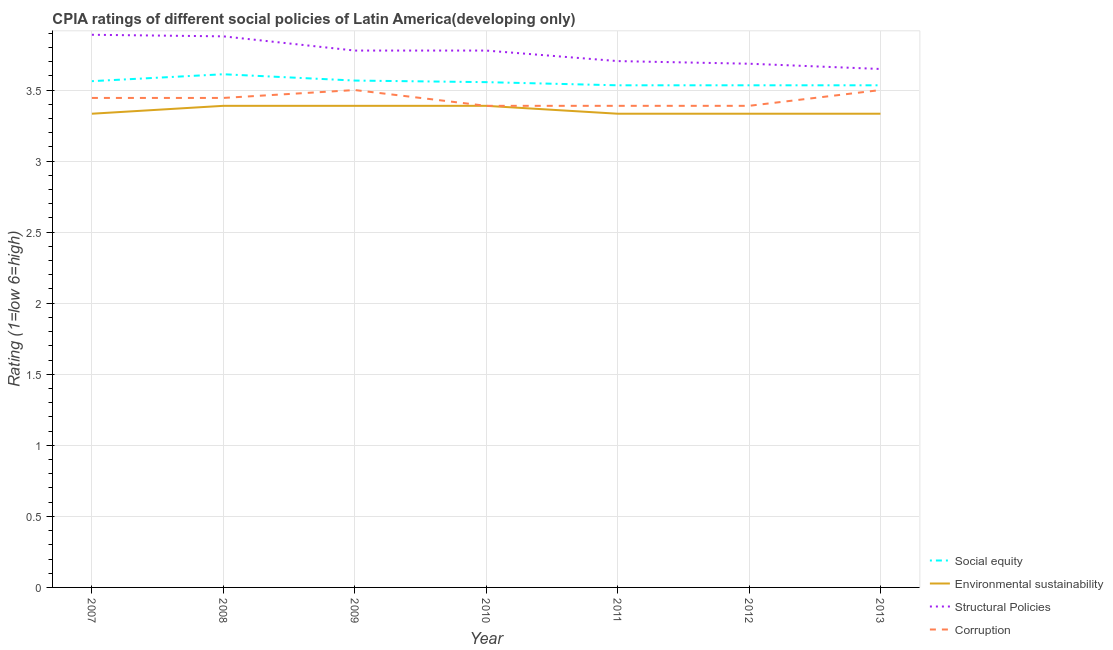Is the number of lines equal to the number of legend labels?
Give a very brief answer. Yes. What is the cpia rating of environmental sustainability in 2012?
Your response must be concise. 3.33. Across all years, what is the minimum cpia rating of corruption?
Make the answer very short. 3.39. What is the total cpia rating of corruption in the graph?
Your response must be concise. 24.06. What is the difference between the cpia rating of social equity in 2009 and the cpia rating of environmental sustainability in 2008?
Ensure brevity in your answer.  0.18. What is the average cpia rating of environmental sustainability per year?
Your answer should be very brief. 3.36. In the year 2011, what is the difference between the cpia rating of environmental sustainability and cpia rating of corruption?
Your answer should be compact. -0.06. In how many years, is the cpia rating of environmental sustainability greater than 2.7?
Give a very brief answer. 7. What is the ratio of the cpia rating of environmental sustainability in 2007 to that in 2012?
Provide a short and direct response. 1. Is the cpia rating of environmental sustainability in 2007 less than that in 2012?
Provide a succinct answer. No. What is the difference between the highest and the second highest cpia rating of social equity?
Make the answer very short. 0.04. What is the difference between the highest and the lowest cpia rating of environmental sustainability?
Offer a very short reply. 0.06. In how many years, is the cpia rating of corruption greater than the average cpia rating of corruption taken over all years?
Make the answer very short. 4. Is the sum of the cpia rating of structural policies in 2007 and 2010 greater than the maximum cpia rating of social equity across all years?
Ensure brevity in your answer.  Yes. Is it the case that in every year, the sum of the cpia rating of corruption and cpia rating of social equity is greater than the sum of cpia rating of environmental sustainability and cpia rating of structural policies?
Ensure brevity in your answer.  No. Is it the case that in every year, the sum of the cpia rating of social equity and cpia rating of environmental sustainability is greater than the cpia rating of structural policies?
Your response must be concise. Yes. Is the cpia rating of corruption strictly greater than the cpia rating of environmental sustainability over the years?
Provide a succinct answer. No. Is the cpia rating of corruption strictly less than the cpia rating of environmental sustainability over the years?
Your answer should be compact. No. How many lines are there?
Offer a terse response. 4. How many years are there in the graph?
Your answer should be compact. 7. Are the values on the major ticks of Y-axis written in scientific E-notation?
Make the answer very short. No. Does the graph contain any zero values?
Your answer should be compact. No. Where does the legend appear in the graph?
Provide a short and direct response. Bottom right. What is the title of the graph?
Your answer should be very brief. CPIA ratings of different social policies of Latin America(developing only). What is the Rating (1=low 6=high) of Social equity in 2007?
Your response must be concise. 3.56. What is the Rating (1=low 6=high) in Environmental sustainability in 2007?
Offer a terse response. 3.33. What is the Rating (1=low 6=high) of Structural Policies in 2007?
Offer a very short reply. 3.89. What is the Rating (1=low 6=high) in Corruption in 2007?
Provide a succinct answer. 3.44. What is the Rating (1=low 6=high) of Social equity in 2008?
Your answer should be compact. 3.61. What is the Rating (1=low 6=high) of Environmental sustainability in 2008?
Your response must be concise. 3.39. What is the Rating (1=low 6=high) of Structural Policies in 2008?
Make the answer very short. 3.88. What is the Rating (1=low 6=high) in Corruption in 2008?
Give a very brief answer. 3.44. What is the Rating (1=low 6=high) in Social equity in 2009?
Your answer should be very brief. 3.57. What is the Rating (1=low 6=high) of Environmental sustainability in 2009?
Provide a short and direct response. 3.39. What is the Rating (1=low 6=high) of Structural Policies in 2009?
Ensure brevity in your answer.  3.78. What is the Rating (1=low 6=high) of Corruption in 2009?
Make the answer very short. 3.5. What is the Rating (1=low 6=high) in Social equity in 2010?
Give a very brief answer. 3.56. What is the Rating (1=low 6=high) in Environmental sustainability in 2010?
Offer a very short reply. 3.39. What is the Rating (1=low 6=high) of Structural Policies in 2010?
Offer a terse response. 3.78. What is the Rating (1=low 6=high) in Corruption in 2010?
Provide a succinct answer. 3.39. What is the Rating (1=low 6=high) of Social equity in 2011?
Provide a succinct answer. 3.53. What is the Rating (1=low 6=high) in Environmental sustainability in 2011?
Give a very brief answer. 3.33. What is the Rating (1=low 6=high) in Structural Policies in 2011?
Offer a terse response. 3.7. What is the Rating (1=low 6=high) in Corruption in 2011?
Keep it short and to the point. 3.39. What is the Rating (1=low 6=high) in Social equity in 2012?
Provide a succinct answer. 3.53. What is the Rating (1=low 6=high) of Environmental sustainability in 2012?
Your response must be concise. 3.33. What is the Rating (1=low 6=high) of Structural Policies in 2012?
Keep it short and to the point. 3.69. What is the Rating (1=low 6=high) in Corruption in 2012?
Give a very brief answer. 3.39. What is the Rating (1=low 6=high) of Social equity in 2013?
Offer a very short reply. 3.53. What is the Rating (1=low 6=high) in Environmental sustainability in 2013?
Offer a very short reply. 3.33. What is the Rating (1=low 6=high) of Structural Policies in 2013?
Your response must be concise. 3.65. Across all years, what is the maximum Rating (1=low 6=high) of Social equity?
Ensure brevity in your answer.  3.61. Across all years, what is the maximum Rating (1=low 6=high) in Environmental sustainability?
Offer a terse response. 3.39. Across all years, what is the maximum Rating (1=low 6=high) in Structural Policies?
Your response must be concise. 3.89. Across all years, what is the minimum Rating (1=low 6=high) of Social equity?
Your answer should be compact. 3.53. Across all years, what is the minimum Rating (1=low 6=high) of Environmental sustainability?
Keep it short and to the point. 3.33. Across all years, what is the minimum Rating (1=low 6=high) in Structural Policies?
Offer a very short reply. 3.65. Across all years, what is the minimum Rating (1=low 6=high) in Corruption?
Provide a succinct answer. 3.39. What is the total Rating (1=low 6=high) of Social equity in the graph?
Offer a very short reply. 24.9. What is the total Rating (1=low 6=high) in Environmental sustainability in the graph?
Provide a short and direct response. 23.5. What is the total Rating (1=low 6=high) in Structural Policies in the graph?
Give a very brief answer. 26.36. What is the total Rating (1=low 6=high) of Corruption in the graph?
Give a very brief answer. 24.06. What is the difference between the Rating (1=low 6=high) in Social equity in 2007 and that in 2008?
Provide a short and direct response. -0.05. What is the difference between the Rating (1=low 6=high) in Environmental sustainability in 2007 and that in 2008?
Make the answer very short. -0.06. What is the difference between the Rating (1=low 6=high) of Structural Policies in 2007 and that in 2008?
Your answer should be very brief. 0.01. What is the difference between the Rating (1=low 6=high) of Social equity in 2007 and that in 2009?
Give a very brief answer. -0. What is the difference between the Rating (1=low 6=high) of Environmental sustainability in 2007 and that in 2009?
Offer a very short reply. -0.06. What is the difference between the Rating (1=low 6=high) in Structural Policies in 2007 and that in 2009?
Provide a succinct answer. 0.11. What is the difference between the Rating (1=low 6=high) of Corruption in 2007 and that in 2009?
Your response must be concise. -0.06. What is the difference between the Rating (1=low 6=high) in Social equity in 2007 and that in 2010?
Keep it short and to the point. 0.01. What is the difference between the Rating (1=low 6=high) of Environmental sustainability in 2007 and that in 2010?
Your response must be concise. -0.06. What is the difference between the Rating (1=low 6=high) in Structural Policies in 2007 and that in 2010?
Your answer should be very brief. 0.11. What is the difference between the Rating (1=low 6=high) in Corruption in 2007 and that in 2010?
Offer a very short reply. 0.06. What is the difference between the Rating (1=low 6=high) in Social equity in 2007 and that in 2011?
Offer a very short reply. 0.03. What is the difference between the Rating (1=low 6=high) in Environmental sustainability in 2007 and that in 2011?
Keep it short and to the point. 0. What is the difference between the Rating (1=low 6=high) in Structural Policies in 2007 and that in 2011?
Provide a short and direct response. 0.19. What is the difference between the Rating (1=low 6=high) of Corruption in 2007 and that in 2011?
Your response must be concise. 0.06. What is the difference between the Rating (1=low 6=high) of Social equity in 2007 and that in 2012?
Make the answer very short. 0.03. What is the difference between the Rating (1=low 6=high) of Structural Policies in 2007 and that in 2012?
Offer a very short reply. 0.2. What is the difference between the Rating (1=low 6=high) of Corruption in 2007 and that in 2012?
Offer a terse response. 0.06. What is the difference between the Rating (1=low 6=high) in Social equity in 2007 and that in 2013?
Make the answer very short. 0.03. What is the difference between the Rating (1=low 6=high) in Structural Policies in 2007 and that in 2013?
Provide a short and direct response. 0.24. What is the difference between the Rating (1=low 6=high) of Corruption in 2007 and that in 2013?
Make the answer very short. -0.06. What is the difference between the Rating (1=low 6=high) in Social equity in 2008 and that in 2009?
Provide a succinct answer. 0.04. What is the difference between the Rating (1=low 6=high) in Environmental sustainability in 2008 and that in 2009?
Ensure brevity in your answer.  0. What is the difference between the Rating (1=low 6=high) of Corruption in 2008 and that in 2009?
Make the answer very short. -0.06. What is the difference between the Rating (1=low 6=high) in Social equity in 2008 and that in 2010?
Provide a succinct answer. 0.06. What is the difference between the Rating (1=low 6=high) of Environmental sustainability in 2008 and that in 2010?
Ensure brevity in your answer.  0. What is the difference between the Rating (1=low 6=high) of Structural Policies in 2008 and that in 2010?
Your answer should be very brief. 0.1. What is the difference between the Rating (1=low 6=high) of Corruption in 2008 and that in 2010?
Give a very brief answer. 0.06. What is the difference between the Rating (1=low 6=high) of Social equity in 2008 and that in 2011?
Give a very brief answer. 0.08. What is the difference between the Rating (1=low 6=high) of Environmental sustainability in 2008 and that in 2011?
Offer a very short reply. 0.06. What is the difference between the Rating (1=low 6=high) in Structural Policies in 2008 and that in 2011?
Ensure brevity in your answer.  0.17. What is the difference between the Rating (1=low 6=high) in Corruption in 2008 and that in 2011?
Provide a succinct answer. 0.06. What is the difference between the Rating (1=low 6=high) in Social equity in 2008 and that in 2012?
Your response must be concise. 0.08. What is the difference between the Rating (1=low 6=high) of Environmental sustainability in 2008 and that in 2012?
Make the answer very short. 0.06. What is the difference between the Rating (1=low 6=high) in Structural Policies in 2008 and that in 2012?
Keep it short and to the point. 0.19. What is the difference between the Rating (1=low 6=high) of Corruption in 2008 and that in 2012?
Make the answer very short. 0.06. What is the difference between the Rating (1=low 6=high) in Social equity in 2008 and that in 2013?
Provide a succinct answer. 0.08. What is the difference between the Rating (1=low 6=high) of Environmental sustainability in 2008 and that in 2013?
Ensure brevity in your answer.  0.06. What is the difference between the Rating (1=low 6=high) of Structural Policies in 2008 and that in 2013?
Provide a succinct answer. 0.23. What is the difference between the Rating (1=low 6=high) of Corruption in 2008 and that in 2013?
Offer a terse response. -0.06. What is the difference between the Rating (1=low 6=high) in Social equity in 2009 and that in 2010?
Your response must be concise. 0.01. What is the difference between the Rating (1=low 6=high) of Environmental sustainability in 2009 and that in 2010?
Your answer should be very brief. 0. What is the difference between the Rating (1=low 6=high) of Environmental sustainability in 2009 and that in 2011?
Provide a short and direct response. 0.06. What is the difference between the Rating (1=low 6=high) in Structural Policies in 2009 and that in 2011?
Provide a succinct answer. 0.07. What is the difference between the Rating (1=low 6=high) in Corruption in 2009 and that in 2011?
Your response must be concise. 0.11. What is the difference between the Rating (1=low 6=high) in Social equity in 2009 and that in 2012?
Your answer should be very brief. 0.03. What is the difference between the Rating (1=low 6=high) in Environmental sustainability in 2009 and that in 2012?
Your response must be concise. 0.06. What is the difference between the Rating (1=low 6=high) of Structural Policies in 2009 and that in 2012?
Keep it short and to the point. 0.09. What is the difference between the Rating (1=low 6=high) in Corruption in 2009 and that in 2012?
Provide a short and direct response. 0.11. What is the difference between the Rating (1=low 6=high) in Social equity in 2009 and that in 2013?
Give a very brief answer. 0.03. What is the difference between the Rating (1=low 6=high) in Environmental sustainability in 2009 and that in 2013?
Keep it short and to the point. 0.06. What is the difference between the Rating (1=low 6=high) of Structural Policies in 2009 and that in 2013?
Make the answer very short. 0.13. What is the difference between the Rating (1=low 6=high) in Social equity in 2010 and that in 2011?
Provide a short and direct response. 0.02. What is the difference between the Rating (1=low 6=high) of Environmental sustainability in 2010 and that in 2011?
Your answer should be very brief. 0.06. What is the difference between the Rating (1=low 6=high) in Structural Policies in 2010 and that in 2011?
Your response must be concise. 0.07. What is the difference between the Rating (1=low 6=high) of Social equity in 2010 and that in 2012?
Your response must be concise. 0.02. What is the difference between the Rating (1=low 6=high) in Environmental sustainability in 2010 and that in 2012?
Make the answer very short. 0.06. What is the difference between the Rating (1=low 6=high) of Structural Policies in 2010 and that in 2012?
Your answer should be very brief. 0.09. What is the difference between the Rating (1=low 6=high) of Social equity in 2010 and that in 2013?
Provide a succinct answer. 0.02. What is the difference between the Rating (1=low 6=high) in Environmental sustainability in 2010 and that in 2013?
Your answer should be compact. 0.06. What is the difference between the Rating (1=low 6=high) of Structural Policies in 2010 and that in 2013?
Provide a succinct answer. 0.13. What is the difference between the Rating (1=low 6=high) in Corruption in 2010 and that in 2013?
Offer a very short reply. -0.11. What is the difference between the Rating (1=low 6=high) in Social equity in 2011 and that in 2012?
Offer a terse response. 0. What is the difference between the Rating (1=low 6=high) of Structural Policies in 2011 and that in 2012?
Your answer should be compact. 0.02. What is the difference between the Rating (1=low 6=high) of Corruption in 2011 and that in 2012?
Make the answer very short. 0. What is the difference between the Rating (1=low 6=high) in Environmental sustainability in 2011 and that in 2013?
Provide a short and direct response. 0. What is the difference between the Rating (1=low 6=high) in Structural Policies in 2011 and that in 2013?
Your answer should be very brief. 0.06. What is the difference between the Rating (1=low 6=high) in Corruption in 2011 and that in 2013?
Offer a very short reply. -0.11. What is the difference between the Rating (1=low 6=high) in Structural Policies in 2012 and that in 2013?
Provide a short and direct response. 0.04. What is the difference between the Rating (1=low 6=high) in Corruption in 2012 and that in 2013?
Offer a terse response. -0.11. What is the difference between the Rating (1=low 6=high) in Social equity in 2007 and the Rating (1=low 6=high) in Environmental sustainability in 2008?
Provide a short and direct response. 0.17. What is the difference between the Rating (1=low 6=high) in Social equity in 2007 and the Rating (1=low 6=high) in Structural Policies in 2008?
Your answer should be compact. -0.32. What is the difference between the Rating (1=low 6=high) in Social equity in 2007 and the Rating (1=low 6=high) in Corruption in 2008?
Make the answer very short. 0.12. What is the difference between the Rating (1=low 6=high) of Environmental sustainability in 2007 and the Rating (1=low 6=high) of Structural Policies in 2008?
Make the answer very short. -0.54. What is the difference between the Rating (1=low 6=high) of Environmental sustainability in 2007 and the Rating (1=low 6=high) of Corruption in 2008?
Offer a terse response. -0.11. What is the difference between the Rating (1=low 6=high) of Structural Policies in 2007 and the Rating (1=low 6=high) of Corruption in 2008?
Ensure brevity in your answer.  0.44. What is the difference between the Rating (1=low 6=high) in Social equity in 2007 and the Rating (1=low 6=high) in Environmental sustainability in 2009?
Provide a short and direct response. 0.17. What is the difference between the Rating (1=low 6=high) in Social equity in 2007 and the Rating (1=low 6=high) in Structural Policies in 2009?
Your answer should be very brief. -0.22. What is the difference between the Rating (1=low 6=high) of Social equity in 2007 and the Rating (1=low 6=high) of Corruption in 2009?
Provide a short and direct response. 0.06. What is the difference between the Rating (1=low 6=high) of Environmental sustainability in 2007 and the Rating (1=low 6=high) of Structural Policies in 2009?
Give a very brief answer. -0.44. What is the difference between the Rating (1=low 6=high) of Structural Policies in 2007 and the Rating (1=low 6=high) of Corruption in 2009?
Ensure brevity in your answer.  0.39. What is the difference between the Rating (1=low 6=high) in Social equity in 2007 and the Rating (1=low 6=high) in Environmental sustainability in 2010?
Make the answer very short. 0.17. What is the difference between the Rating (1=low 6=high) in Social equity in 2007 and the Rating (1=low 6=high) in Structural Policies in 2010?
Keep it short and to the point. -0.22. What is the difference between the Rating (1=low 6=high) of Social equity in 2007 and the Rating (1=low 6=high) of Corruption in 2010?
Keep it short and to the point. 0.17. What is the difference between the Rating (1=low 6=high) in Environmental sustainability in 2007 and the Rating (1=low 6=high) in Structural Policies in 2010?
Your response must be concise. -0.44. What is the difference between the Rating (1=low 6=high) in Environmental sustainability in 2007 and the Rating (1=low 6=high) in Corruption in 2010?
Your answer should be very brief. -0.06. What is the difference between the Rating (1=low 6=high) of Structural Policies in 2007 and the Rating (1=low 6=high) of Corruption in 2010?
Offer a very short reply. 0.5. What is the difference between the Rating (1=low 6=high) in Social equity in 2007 and the Rating (1=low 6=high) in Environmental sustainability in 2011?
Keep it short and to the point. 0.23. What is the difference between the Rating (1=low 6=high) of Social equity in 2007 and the Rating (1=low 6=high) of Structural Policies in 2011?
Keep it short and to the point. -0.14. What is the difference between the Rating (1=low 6=high) in Social equity in 2007 and the Rating (1=low 6=high) in Corruption in 2011?
Make the answer very short. 0.17. What is the difference between the Rating (1=low 6=high) of Environmental sustainability in 2007 and the Rating (1=low 6=high) of Structural Policies in 2011?
Ensure brevity in your answer.  -0.37. What is the difference between the Rating (1=low 6=high) of Environmental sustainability in 2007 and the Rating (1=low 6=high) of Corruption in 2011?
Give a very brief answer. -0.06. What is the difference between the Rating (1=low 6=high) in Social equity in 2007 and the Rating (1=low 6=high) in Environmental sustainability in 2012?
Your answer should be compact. 0.23. What is the difference between the Rating (1=low 6=high) in Social equity in 2007 and the Rating (1=low 6=high) in Structural Policies in 2012?
Offer a terse response. -0.12. What is the difference between the Rating (1=low 6=high) in Social equity in 2007 and the Rating (1=low 6=high) in Corruption in 2012?
Your response must be concise. 0.17. What is the difference between the Rating (1=low 6=high) of Environmental sustainability in 2007 and the Rating (1=low 6=high) of Structural Policies in 2012?
Your answer should be compact. -0.35. What is the difference between the Rating (1=low 6=high) of Environmental sustainability in 2007 and the Rating (1=low 6=high) of Corruption in 2012?
Provide a succinct answer. -0.06. What is the difference between the Rating (1=low 6=high) of Social equity in 2007 and the Rating (1=low 6=high) of Environmental sustainability in 2013?
Ensure brevity in your answer.  0.23. What is the difference between the Rating (1=low 6=high) in Social equity in 2007 and the Rating (1=low 6=high) in Structural Policies in 2013?
Give a very brief answer. -0.09. What is the difference between the Rating (1=low 6=high) in Social equity in 2007 and the Rating (1=low 6=high) in Corruption in 2013?
Keep it short and to the point. 0.06. What is the difference between the Rating (1=low 6=high) in Environmental sustainability in 2007 and the Rating (1=low 6=high) in Structural Policies in 2013?
Provide a succinct answer. -0.31. What is the difference between the Rating (1=low 6=high) in Environmental sustainability in 2007 and the Rating (1=low 6=high) in Corruption in 2013?
Provide a short and direct response. -0.17. What is the difference between the Rating (1=low 6=high) in Structural Policies in 2007 and the Rating (1=low 6=high) in Corruption in 2013?
Provide a succinct answer. 0.39. What is the difference between the Rating (1=low 6=high) of Social equity in 2008 and the Rating (1=low 6=high) of Environmental sustainability in 2009?
Your answer should be very brief. 0.22. What is the difference between the Rating (1=low 6=high) in Social equity in 2008 and the Rating (1=low 6=high) in Structural Policies in 2009?
Offer a terse response. -0.17. What is the difference between the Rating (1=low 6=high) in Environmental sustainability in 2008 and the Rating (1=low 6=high) in Structural Policies in 2009?
Your response must be concise. -0.39. What is the difference between the Rating (1=low 6=high) of Environmental sustainability in 2008 and the Rating (1=low 6=high) of Corruption in 2009?
Ensure brevity in your answer.  -0.11. What is the difference between the Rating (1=low 6=high) of Structural Policies in 2008 and the Rating (1=low 6=high) of Corruption in 2009?
Your response must be concise. 0.38. What is the difference between the Rating (1=low 6=high) of Social equity in 2008 and the Rating (1=low 6=high) of Environmental sustainability in 2010?
Provide a succinct answer. 0.22. What is the difference between the Rating (1=low 6=high) in Social equity in 2008 and the Rating (1=low 6=high) in Corruption in 2010?
Your response must be concise. 0.22. What is the difference between the Rating (1=low 6=high) of Environmental sustainability in 2008 and the Rating (1=low 6=high) of Structural Policies in 2010?
Your response must be concise. -0.39. What is the difference between the Rating (1=low 6=high) of Structural Policies in 2008 and the Rating (1=low 6=high) of Corruption in 2010?
Make the answer very short. 0.49. What is the difference between the Rating (1=low 6=high) of Social equity in 2008 and the Rating (1=low 6=high) of Environmental sustainability in 2011?
Offer a very short reply. 0.28. What is the difference between the Rating (1=low 6=high) of Social equity in 2008 and the Rating (1=low 6=high) of Structural Policies in 2011?
Offer a very short reply. -0.09. What is the difference between the Rating (1=low 6=high) of Social equity in 2008 and the Rating (1=low 6=high) of Corruption in 2011?
Offer a terse response. 0.22. What is the difference between the Rating (1=low 6=high) of Environmental sustainability in 2008 and the Rating (1=low 6=high) of Structural Policies in 2011?
Make the answer very short. -0.31. What is the difference between the Rating (1=low 6=high) of Environmental sustainability in 2008 and the Rating (1=low 6=high) of Corruption in 2011?
Provide a short and direct response. 0. What is the difference between the Rating (1=low 6=high) in Structural Policies in 2008 and the Rating (1=low 6=high) in Corruption in 2011?
Offer a very short reply. 0.49. What is the difference between the Rating (1=low 6=high) in Social equity in 2008 and the Rating (1=low 6=high) in Environmental sustainability in 2012?
Provide a succinct answer. 0.28. What is the difference between the Rating (1=low 6=high) in Social equity in 2008 and the Rating (1=low 6=high) in Structural Policies in 2012?
Offer a very short reply. -0.07. What is the difference between the Rating (1=low 6=high) of Social equity in 2008 and the Rating (1=low 6=high) of Corruption in 2012?
Keep it short and to the point. 0.22. What is the difference between the Rating (1=low 6=high) in Environmental sustainability in 2008 and the Rating (1=low 6=high) in Structural Policies in 2012?
Ensure brevity in your answer.  -0.3. What is the difference between the Rating (1=low 6=high) of Environmental sustainability in 2008 and the Rating (1=low 6=high) of Corruption in 2012?
Provide a short and direct response. 0. What is the difference between the Rating (1=low 6=high) in Structural Policies in 2008 and the Rating (1=low 6=high) in Corruption in 2012?
Your answer should be compact. 0.49. What is the difference between the Rating (1=low 6=high) in Social equity in 2008 and the Rating (1=low 6=high) in Environmental sustainability in 2013?
Keep it short and to the point. 0.28. What is the difference between the Rating (1=low 6=high) in Social equity in 2008 and the Rating (1=low 6=high) in Structural Policies in 2013?
Offer a very short reply. -0.04. What is the difference between the Rating (1=low 6=high) in Environmental sustainability in 2008 and the Rating (1=low 6=high) in Structural Policies in 2013?
Your response must be concise. -0.26. What is the difference between the Rating (1=low 6=high) in Environmental sustainability in 2008 and the Rating (1=low 6=high) in Corruption in 2013?
Your response must be concise. -0.11. What is the difference between the Rating (1=low 6=high) of Structural Policies in 2008 and the Rating (1=low 6=high) of Corruption in 2013?
Provide a succinct answer. 0.38. What is the difference between the Rating (1=low 6=high) in Social equity in 2009 and the Rating (1=low 6=high) in Environmental sustainability in 2010?
Provide a succinct answer. 0.18. What is the difference between the Rating (1=low 6=high) in Social equity in 2009 and the Rating (1=low 6=high) in Structural Policies in 2010?
Offer a very short reply. -0.21. What is the difference between the Rating (1=low 6=high) in Social equity in 2009 and the Rating (1=low 6=high) in Corruption in 2010?
Your response must be concise. 0.18. What is the difference between the Rating (1=low 6=high) of Environmental sustainability in 2009 and the Rating (1=low 6=high) of Structural Policies in 2010?
Your response must be concise. -0.39. What is the difference between the Rating (1=low 6=high) of Structural Policies in 2009 and the Rating (1=low 6=high) of Corruption in 2010?
Your answer should be compact. 0.39. What is the difference between the Rating (1=low 6=high) in Social equity in 2009 and the Rating (1=low 6=high) in Environmental sustainability in 2011?
Your answer should be very brief. 0.23. What is the difference between the Rating (1=low 6=high) in Social equity in 2009 and the Rating (1=low 6=high) in Structural Policies in 2011?
Give a very brief answer. -0.14. What is the difference between the Rating (1=low 6=high) of Social equity in 2009 and the Rating (1=low 6=high) of Corruption in 2011?
Your answer should be compact. 0.18. What is the difference between the Rating (1=low 6=high) in Environmental sustainability in 2009 and the Rating (1=low 6=high) in Structural Policies in 2011?
Give a very brief answer. -0.31. What is the difference between the Rating (1=low 6=high) in Environmental sustainability in 2009 and the Rating (1=low 6=high) in Corruption in 2011?
Offer a terse response. 0. What is the difference between the Rating (1=low 6=high) in Structural Policies in 2009 and the Rating (1=low 6=high) in Corruption in 2011?
Your answer should be very brief. 0.39. What is the difference between the Rating (1=low 6=high) in Social equity in 2009 and the Rating (1=low 6=high) in Environmental sustainability in 2012?
Make the answer very short. 0.23. What is the difference between the Rating (1=low 6=high) in Social equity in 2009 and the Rating (1=low 6=high) in Structural Policies in 2012?
Offer a terse response. -0.12. What is the difference between the Rating (1=low 6=high) of Social equity in 2009 and the Rating (1=low 6=high) of Corruption in 2012?
Offer a terse response. 0.18. What is the difference between the Rating (1=low 6=high) in Environmental sustainability in 2009 and the Rating (1=low 6=high) in Structural Policies in 2012?
Provide a succinct answer. -0.3. What is the difference between the Rating (1=low 6=high) of Structural Policies in 2009 and the Rating (1=low 6=high) of Corruption in 2012?
Your answer should be very brief. 0.39. What is the difference between the Rating (1=low 6=high) in Social equity in 2009 and the Rating (1=low 6=high) in Environmental sustainability in 2013?
Your answer should be very brief. 0.23. What is the difference between the Rating (1=low 6=high) in Social equity in 2009 and the Rating (1=low 6=high) in Structural Policies in 2013?
Keep it short and to the point. -0.08. What is the difference between the Rating (1=low 6=high) of Social equity in 2009 and the Rating (1=low 6=high) of Corruption in 2013?
Ensure brevity in your answer.  0.07. What is the difference between the Rating (1=low 6=high) of Environmental sustainability in 2009 and the Rating (1=low 6=high) of Structural Policies in 2013?
Your answer should be very brief. -0.26. What is the difference between the Rating (1=low 6=high) of Environmental sustainability in 2009 and the Rating (1=low 6=high) of Corruption in 2013?
Provide a short and direct response. -0.11. What is the difference between the Rating (1=low 6=high) in Structural Policies in 2009 and the Rating (1=low 6=high) in Corruption in 2013?
Give a very brief answer. 0.28. What is the difference between the Rating (1=low 6=high) in Social equity in 2010 and the Rating (1=low 6=high) in Environmental sustainability in 2011?
Ensure brevity in your answer.  0.22. What is the difference between the Rating (1=low 6=high) of Social equity in 2010 and the Rating (1=low 6=high) of Structural Policies in 2011?
Give a very brief answer. -0.15. What is the difference between the Rating (1=low 6=high) of Environmental sustainability in 2010 and the Rating (1=low 6=high) of Structural Policies in 2011?
Make the answer very short. -0.31. What is the difference between the Rating (1=low 6=high) of Structural Policies in 2010 and the Rating (1=low 6=high) of Corruption in 2011?
Provide a succinct answer. 0.39. What is the difference between the Rating (1=low 6=high) in Social equity in 2010 and the Rating (1=low 6=high) in Environmental sustainability in 2012?
Offer a very short reply. 0.22. What is the difference between the Rating (1=low 6=high) in Social equity in 2010 and the Rating (1=low 6=high) in Structural Policies in 2012?
Offer a very short reply. -0.13. What is the difference between the Rating (1=low 6=high) in Environmental sustainability in 2010 and the Rating (1=low 6=high) in Structural Policies in 2012?
Make the answer very short. -0.3. What is the difference between the Rating (1=low 6=high) in Environmental sustainability in 2010 and the Rating (1=low 6=high) in Corruption in 2012?
Provide a succinct answer. 0. What is the difference between the Rating (1=low 6=high) of Structural Policies in 2010 and the Rating (1=low 6=high) of Corruption in 2012?
Your answer should be compact. 0.39. What is the difference between the Rating (1=low 6=high) in Social equity in 2010 and the Rating (1=low 6=high) in Environmental sustainability in 2013?
Offer a very short reply. 0.22. What is the difference between the Rating (1=low 6=high) of Social equity in 2010 and the Rating (1=low 6=high) of Structural Policies in 2013?
Give a very brief answer. -0.09. What is the difference between the Rating (1=low 6=high) in Social equity in 2010 and the Rating (1=low 6=high) in Corruption in 2013?
Provide a short and direct response. 0.06. What is the difference between the Rating (1=low 6=high) in Environmental sustainability in 2010 and the Rating (1=low 6=high) in Structural Policies in 2013?
Ensure brevity in your answer.  -0.26. What is the difference between the Rating (1=low 6=high) of Environmental sustainability in 2010 and the Rating (1=low 6=high) of Corruption in 2013?
Ensure brevity in your answer.  -0.11. What is the difference between the Rating (1=low 6=high) of Structural Policies in 2010 and the Rating (1=low 6=high) of Corruption in 2013?
Your response must be concise. 0.28. What is the difference between the Rating (1=low 6=high) of Social equity in 2011 and the Rating (1=low 6=high) of Environmental sustainability in 2012?
Make the answer very short. 0.2. What is the difference between the Rating (1=low 6=high) of Social equity in 2011 and the Rating (1=low 6=high) of Structural Policies in 2012?
Offer a very short reply. -0.15. What is the difference between the Rating (1=low 6=high) of Social equity in 2011 and the Rating (1=low 6=high) of Corruption in 2012?
Your answer should be very brief. 0.14. What is the difference between the Rating (1=low 6=high) in Environmental sustainability in 2011 and the Rating (1=low 6=high) in Structural Policies in 2012?
Your response must be concise. -0.35. What is the difference between the Rating (1=low 6=high) of Environmental sustainability in 2011 and the Rating (1=low 6=high) of Corruption in 2012?
Provide a short and direct response. -0.06. What is the difference between the Rating (1=low 6=high) of Structural Policies in 2011 and the Rating (1=low 6=high) of Corruption in 2012?
Your answer should be compact. 0.31. What is the difference between the Rating (1=low 6=high) in Social equity in 2011 and the Rating (1=low 6=high) in Environmental sustainability in 2013?
Make the answer very short. 0.2. What is the difference between the Rating (1=low 6=high) of Social equity in 2011 and the Rating (1=low 6=high) of Structural Policies in 2013?
Provide a succinct answer. -0.11. What is the difference between the Rating (1=low 6=high) in Environmental sustainability in 2011 and the Rating (1=low 6=high) in Structural Policies in 2013?
Offer a very short reply. -0.31. What is the difference between the Rating (1=low 6=high) in Environmental sustainability in 2011 and the Rating (1=low 6=high) in Corruption in 2013?
Keep it short and to the point. -0.17. What is the difference between the Rating (1=low 6=high) in Structural Policies in 2011 and the Rating (1=low 6=high) in Corruption in 2013?
Keep it short and to the point. 0.2. What is the difference between the Rating (1=low 6=high) in Social equity in 2012 and the Rating (1=low 6=high) in Environmental sustainability in 2013?
Make the answer very short. 0.2. What is the difference between the Rating (1=low 6=high) of Social equity in 2012 and the Rating (1=low 6=high) of Structural Policies in 2013?
Provide a succinct answer. -0.11. What is the difference between the Rating (1=low 6=high) of Social equity in 2012 and the Rating (1=low 6=high) of Corruption in 2013?
Ensure brevity in your answer.  0.03. What is the difference between the Rating (1=low 6=high) in Environmental sustainability in 2012 and the Rating (1=low 6=high) in Structural Policies in 2013?
Provide a succinct answer. -0.31. What is the difference between the Rating (1=low 6=high) in Environmental sustainability in 2012 and the Rating (1=low 6=high) in Corruption in 2013?
Give a very brief answer. -0.17. What is the difference between the Rating (1=low 6=high) in Structural Policies in 2012 and the Rating (1=low 6=high) in Corruption in 2013?
Your answer should be very brief. 0.19. What is the average Rating (1=low 6=high) of Social equity per year?
Your response must be concise. 3.56. What is the average Rating (1=low 6=high) in Environmental sustainability per year?
Your answer should be very brief. 3.36. What is the average Rating (1=low 6=high) in Structural Policies per year?
Offer a very short reply. 3.77. What is the average Rating (1=low 6=high) of Corruption per year?
Make the answer very short. 3.44. In the year 2007, what is the difference between the Rating (1=low 6=high) of Social equity and Rating (1=low 6=high) of Environmental sustainability?
Your answer should be very brief. 0.23. In the year 2007, what is the difference between the Rating (1=low 6=high) of Social equity and Rating (1=low 6=high) of Structural Policies?
Your answer should be compact. -0.33. In the year 2007, what is the difference between the Rating (1=low 6=high) of Social equity and Rating (1=low 6=high) of Corruption?
Provide a succinct answer. 0.12. In the year 2007, what is the difference between the Rating (1=low 6=high) of Environmental sustainability and Rating (1=low 6=high) of Structural Policies?
Your answer should be compact. -0.56. In the year 2007, what is the difference between the Rating (1=low 6=high) in Environmental sustainability and Rating (1=low 6=high) in Corruption?
Make the answer very short. -0.11. In the year 2007, what is the difference between the Rating (1=low 6=high) in Structural Policies and Rating (1=low 6=high) in Corruption?
Your answer should be compact. 0.44. In the year 2008, what is the difference between the Rating (1=low 6=high) in Social equity and Rating (1=low 6=high) in Environmental sustainability?
Provide a succinct answer. 0.22. In the year 2008, what is the difference between the Rating (1=low 6=high) of Social equity and Rating (1=low 6=high) of Structural Policies?
Ensure brevity in your answer.  -0.27. In the year 2008, what is the difference between the Rating (1=low 6=high) in Social equity and Rating (1=low 6=high) in Corruption?
Your answer should be very brief. 0.17. In the year 2008, what is the difference between the Rating (1=low 6=high) of Environmental sustainability and Rating (1=low 6=high) of Structural Policies?
Give a very brief answer. -0.49. In the year 2008, what is the difference between the Rating (1=low 6=high) of Environmental sustainability and Rating (1=low 6=high) of Corruption?
Keep it short and to the point. -0.06. In the year 2008, what is the difference between the Rating (1=low 6=high) in Structural Policies and Rating (1=low 6=high) in Corruption?
Offer a very short reply. 0.43. In the year 2009, what is the difference between the Rating (1=low 6=high) in Social equity and Rating (1=low 6=high) in Environmental sustainability?
Your response must be concise. 0.18. In the year 2009, what is the difference between the Rating (1=low 6=high) in Social equity and Rating (1=low 6=high) in Structural Policies?
Provide a short and direct response. -0.21. In the year 2009, what is the difference between the Rating (1=low 6=high) of Social equity and Rating (1=low 6=high) of Corruption?
Offer a terse response. 0.07. In the year 2009, what is the difference between the Rating (1=low 6=high) in Environmental sustainability and Rating (1=low 6=high) in Structural Policies?
Give a very brief answer. -0.39. In the year 2009, what is the difference between the Rating (1=low 6=high) in Environmental sustainability and Rating (1=low 6=high) in Corruption?
Offer a very short reply. -0.11. In the year 2009, what is the difference between the Rating (1=low 6=high) in Structural Policies and Rating (1=low 6=high) in Corruption?
Keep it short and to the point. 0.28. In the year 2010, what is the difference between the Rating (1=low 6=high) of Social equity and Rating (1=low 6=high) of Environmental sustainability?
Your answer should be compact. 0.17. In the year 2010, what is the difference between the Rating (1=low 6=high) of Social equity and Rating (1=low 6=high) of Structural Policies?
Your answer should be very brief. -0.22. In the year 2010, what is the difference between the Rating (1=low 6=high) in Social equity and Rating (1=low 6=high) in Corruption?
Give a very brief answer. 0.17. In the year 2010, what is the difference between the Rating (1=low 6=high) of Environmental sustainability and Rating (1=low 6=high) of Structural Policies?
Your answer should be very brief. -0.39. In the year 2010, what is the difference between the Rating (1=low 6=high) in Environmental sustainability and Rating (1=low 6=high) in Corruption?
Provide a short and direct response. 0. In the year 2010, what is the difference between the Rating (1=low 6=high) of Structural Policies and Rating (1=low 6=high) of Corruption?
Give a very brief answer. 0.39. In the year 2011, what is the difference between the Rating (1=low 6=high) of Social equity and Rating (1=low 6=high) of Environmental sustainability?
Provide a succinct answer. 0.2. In the year 2011, what is the difference between the Rating (1=low 6=high) of Social equity and Rating (1=low 6=high) of Structural Policies?
Your answer should be very brief. -0.17. In the year 2011, what is the difference between the Rating (1=low 6=high) of Social equity and Rating (1=low 6=high) of Corruption?
Your answer should be very brief. 0.14. In the year 2011, what is the difference between the Rating (1=low 6=high) in Environmental sustainability and Rating (1=low 6=high) in Structural Policies?
Your response must be concise. -0.37. In the year 2011, what is the difference between the Rating (1=low 6=high) of Environmental sustainability and Rating (1=low 6=high) of Corruption?
Keep it short and to the point. -0.06. In the year 2011, what is the difference between the Rating (1=low 6=high) of Structural Policies and Rating (1=low 6=high) of Corruption?
Offer a terse response. 0.31. In the year 2012, what is the difference between the Rating (1=low 6=high) in Social equity and Rating (1=low 6=high) in Structural Policies?
Keep it short and to the point. -0.15. In the year 2012, what is the difference between the Rating (1=low 6=high) in Social equity and Rating (1=low 6=high) in Corruption?
Your response must be concise. 0.14. In the year 2012, what is the difference between the Rating (1=low 6=high) of Environmental sustainability and Rating (1=low 6=high) of Structural Policies?
Provide a succinct answer. -0.35. In the year 2012, what is the difference between the Rating (1=low 6=high) of Environmental sustainability and Rating (1=low 6=high) of Corruption?
Ensure brevity in your answer.  -0.06. In the year 2012, what is the difference between the Rating (1=low 6=high) in Structural Policies and Rating (1=low 6=high) in Corruption?
Provide a short and direct response. 0.3. In the year 2013, what is the difference between the Rating (1=low 6=high) of Social equity and Rating (1=low 6=high) of Structural Policies?
Your response must be concise. -0.11. In the year 2013, what is the difference between the Rating (1=low 6=high) in Environmental sustainability and Rating (1=low 6=high) in Structural Policies?
Offer a very short reply. -0.31. In the year 2013, what is the difference between the Rating (1=low 6=high) of Structural Policies and Rating (1=low 6=high) of Corruption?
Keep it short and to the point. 0.15. What is the ratio of the Rating (1=low 6=high) of Social equity in 2007 to that in 2008?
Keep it short and to the point. 0.99. What is the ratio of the Rating (1=low 6=high) in Environmental sustainability in 2007 to that in 2008?
Provide a succinct answer. 0.98. What is the ratio of the Rating (1=low 6=high) in Structural Policies in 2007 to that in 2008?
Provide a short and direct response. 1. What is the ratio of the Rating (1=low 6=high) of Environmental sustainability in 2007 to that in 2009?
Ensure brevity in your answer.  0.98. What is the ratio of the Rating (1=low 6=high) in Structural Policies in 2007 to that in 2009?
Offer a terse response. 1.03. What is the ratio of the Rating (1=low 6=high) of Corruption in 2007 to that in 2009?
Make the answer very short. 0.98. What is the ratio of the Rating (1=low 6=high) of Social equity in 2007 to that in 2010?
Your answer should be compact. 1. What is the ratio of the Rating (1=low 6=high) of Environmental sustainability in 2007 to that in 2010?
Your answer should be very brief. 0.98. What is the ratio of the Rating (1=low 6=high) of Structural Policies in 2007 to that in 2010?
Your answer should be compact. 1.03. What is the ratio of the Rating (1=low 6=high) in Corruption in 2007 to that in 2010?
Ensure brevity in your answer.  1.02. What is the ratio of the Rating (1=low 6=high) in Social equity in 2007 to that in 2011?
Your answer should be compact. 1.01. What is the ratio of the Rating (1=low 6=high) in Corruption in 2007 to that in 2011?
Make the answer very short. 1.02. What is the ratio of the Rating (1=low 6=high) of Social equity in 2007 to that in 2012?
Provide a succinct answer. 1.01. What is the ratio of the Rating (1=low 6=high) in Structural Policies in 2007 to that in 2012?
Provide a succinct answer. 1.06. What is the ratio of the Rating (1=low 6=high) in Corruption in 2007 to that in 2012?
Offer a very short reply. 1.02. What is the ratio of the Rating (1=low 6=high) in Social equity in 2007 to that in 2013?
Offer a very short reply. 1.01. What is the ratio of the Rating (1=low 6=high) in Environmental sustainability in 2007 to that in 2013?
Keep it short and to the point. 1. What is the ratio of the Rating (1=low 6=high) of Structural Policies in 2007 to that in 2013?
Your answer should be very brief. 1.07. What is the ratio of the Rating (1=low 6=high) of Corruption in 2007 to that in 2013?
Keep it short and to the point. 0.98. What is the ratio of the Rating (1=low 6=high) in Social equity in 2008 to that in 2009?
Make the answer very short. 1.01. What is the ratio of the Rating (1=low 6=high) in Structural Policies in 2008 to that in 2009?
Your answer should be compact. 1.03. What is the ratio of the Rating (1=low 6=high) of Corruption in 2008 to that in 2009?
Offer a very short reply. 0.98. What is the ratio of the Rating (1=low 6=high) of Social equity in 2008 to that in 2010?
Offer a very short reply. 1.02. What is the ratio of the Rating (1=low 6=high) of Structural Policies in 2008 to that in 2010?
Provide a short and direct response. 1.03. What is the ratio of the Rating (1=low 6=high) of Corruption in 2008 to that in 2010?
Keep it short and to the point. 1.02. What is the ratio of the Rating (1=low 6=high) in Environmental sustainability in 2008 to that in 2011?
Offer a very short reply. 1.02. What is the ratio of the Rating (1=low 6=high) in Structural Policies in 2008 to that in 2011?
Your answer should be compact. 1.05. What is the ratio of the Rating (1=low 6=high) in Corruption in 2008 to that in 2011?
Offer a terse response. 1.02. What is the ratio of the Rating (1=low 6=high) of Social equity in 2008 to that in 2012?
Provide a succinct answer. 1.02. What is the ratio of the Rating (1=low 6=high) in Environmental sustainability in 2008 to that in 2012?
Provide a short and direct response. 1.02. What is the ratio of the Rating (1=low 6=high) in Structural Policies in 2008 to that in 2012?
Provide a succinct answer. 1.05. What is the ratio of the Rating (1=low 6=high) in Corruption in 2008 to that in 2012?
Give a very brief answer. 1.02. What is the ratio of the Rating (1=low 6=high) of Environmental sustainability in 2008 to that in 2013?
Your answer should be compact. 1.02. What is the ratio of the Rating (1=low 6=high) in Structural Policies in 2008 to that in 2013?
Your answer should be very brief. 1.06. What is the ratio of the Rating (1=low 6=high) in Corruption in 2008 to that in 2013?
Keep it short and to the point. 0.98. What is the ratio of the Rating (1=low 6=high) in Social equity in 2009 to that in 2010?
Your answer should be compact. 1. What is the ratio of the Rating (1=low 6=high) of Environmental sustainability in 2009 to that in 2010?
Provide a short and direct response. 1. What is the ratio of the Rating (1=low 6=high) in Corruption in 2009 to that in 2010?
Offer a terse response. 1.03. What is the ratio of the Rating (1=low 6=high) in Social equity in 2009 to that in 2011?
Your answer should be very brief. 1.01. What is the ratio of the Rating (1=low 6=high) of Environmental sustainability in 2009 to that in 2011?
Ensure brevity in your answer.  1.02. What is the ratio of the Rating (1=low 6=high) of Structural Policies in 2009 to that in 2011?
Ensure brevity in your answer.  1.02. What is the ratio of the Rating (1=low 6=high) in Corruption in 2009 to that in 2011?
Offer a terse response. 1.03. What is the ratio of the Rating (1=low 6=high) of Social equity in 2009 to that in 2012?
Ensure brevity in your answer.  1.01. What is the ratio of the Rating (1=low 6=high) in Environmental sustainability in 2009 to that in 2012?
Your answer should be very brief. 1.02. What is the ratio of the Rating (1=low 6=high) in Structural Policies in 2009 to that in 2012?
Provide a succinct answer. 1.03. What is the ratio of the Rating (1=low 6=high) of Corruption in 2009 to that in 2012?
Your response must be concise. 1.03. What is the ratio of the Rating (1=low 6=high) in Social equity in 2009 to that in 2013?
Your answer should be compact. 1.01. What is the ratio of the Rating (1=low 6=high) of Environmental sustainability in 2009 to that in 2013?
Your answer should be very brief. 1.02. What is the ratio of the Rating (1=low 6=high) of Structural Policies in 2009 to that in 2013?
Offer a terse response. 1.04. What is the ratio of the Rating (1=low 6=high) in Corruption in 2009 to that in 2013?
Provide a succinct answer. 1. What is the ratio of the Rating (1=low 6=high) in Environmental sustainability in 2010 to that in 2011?
Provide a succinct answer. 1.02. What is the ratio of the Rating (1=low 6=high) in Environmental sustainability in 2010 to that in 2012?
Your response must be concise. 1.02. What is the ratio of the Rating (1=low 6=high) in Structural Policies in 2010 to that in 2012?
Provide a succinct answer. 1.03. What is the ratio of the Rating (1=low 6=high) of Corruption in 2010 to that in 2012?
Ensure brevity in your answer.  1. What is the ratio of the Rating (1=low 6=high) in Environmental sustainability in 2010 to that in 2013?
Offer a very short reply. 1.02. What is the ratio of the Rating (1=low 6=high) of Structural Policies in 2010 to that in 2013?
Your response must be concise. 1.04. What is the ratio of the Rating (1=low 6=high) of Corruption in 2010 to that in 2013?
Make the answer very short. 0.97. What is the ratio of the Rating (1=low 6=high) in Environmental sustainability in 2011 to that in 2012?
Your response must be concise. 1. What is the ratio of the Rating (1=low 6=high) in Social equity in 2011 to that in 2013?
Provide a succinct answer. 1. What is the ratio of the Rating (1=low 6=high) in Structural Policies in 2011 to that in 2013?
Offer a very short reply. 1.02. What is the ratio of the Rating (1=low 6=high) of Corruption in 2011 to that in 2013?
Ensure brevity in your answer.  0.97. What is the ratio of the Rating (1=low 6=high) in Structural Policies in 2012 to that in 2013?
Ensure brevity in your answer.  1.01. What is the ratio of the Rating (1=low 6=high) in Corruption in 2012 to that in 2013?
Ensure brevity in your answer.  0.97. What is the difference between the highest and the second highest Rating (1=low 6=high) in Social equity?
Your response must be concise. 0.04. What is the difference between the highest and the second highest Rating (1=low 6=high) in Structural Policies?
Your answer should be very brief. 0.01. What is the difference between the highest and the lowest Rating (1=low 6=high) of Social equity?
Your answer should be compact. 0.08. What is the difference between the highest and the lowest Rating (1=low 6=high) in Environmental sustainability?
Offer a very short reply. 0.06. What is the difference between the highest and the lowest Rating (1=low 6=high) of Structural Policies?
Provide a short and direct response. 0.24. What is the difference between the highest and the lowest Rating (1=low 6=high) of Corruption?
Provide a succinct answer. 0.11. 